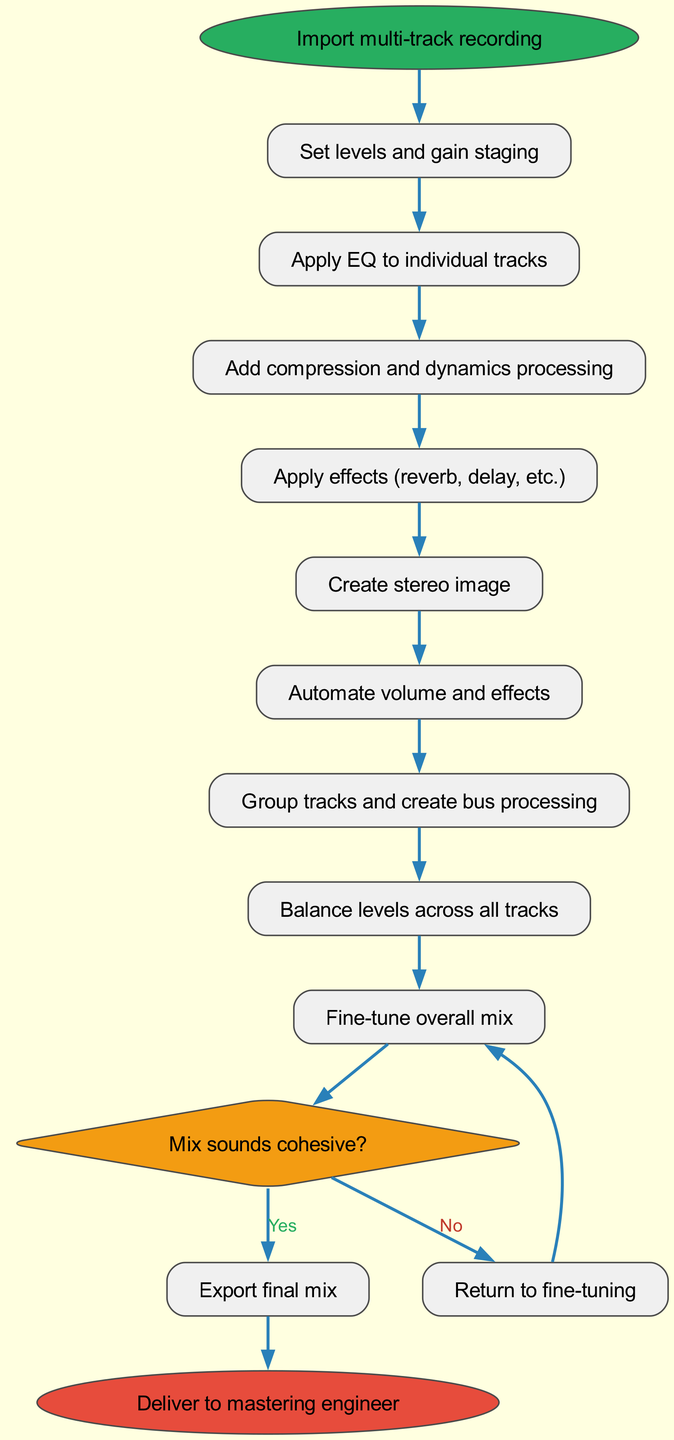What is the first step in the mixing process? The first step is indicated in the diagram as "Import multi-track recording". It is represented as the first node in the flowchart, directly following the start node.
Answer: Import multi-track recording How many steps are there in the mixing process? By counting the listed steps in the diagram, there are a total of 8 process steps leading to the decision point.
Answer: 8 What happens after reaching the decision point and the answer is "Yes"? After the decision point, if the answer is "Yes", the process moves to the "Export final mix" step, which is a direct output from the decision node.
Answer: Export final mix What is the last step in the mixing process? The diagram illustrates that the final step, which follows the "Export final mix" step after a "Yes" decision, is "Deliver to mastering engineer".
Answer: Deliver to mastering engineer What is the decision question in the flowchart? The decision question posed in the diagram is "Mix sounds cohesive?", which determines the subsequent path in the process.
Answer: Mix sounds cohesive? What is the next step if the answer to the decision is "No"? If the answer to the decision is "No", the process loops back to "Fine-tune overall mix", allowing for adjustments before retesting the mix's cohesiveness.
Answer: Fine-tune overall mix How many nodes are there in total in this diagram? To find the total number of nodes, we count each unique step, decision, and end point: 8 steps + 1 decision + 1 start + 1 end, which results in 11 nodes total.
Answer: 11 Which step involves adjusting volumes and effects? The step that involves adjusting volumes and effects is "Automate volume and effects" as indicated in the sequence of the processing steps before reaching the decision point.
Answer: Automate volume and effects 